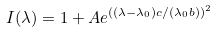<formula> <loc_0><loc_0><loc_500><loc_500>I ( \lambda ) = 1 + A e ^ { ( ( \lambda - \lambda _ { 0 } ) c / ( \lambda _ { 0 } b ) ) ^ { 2 } }</formula> 